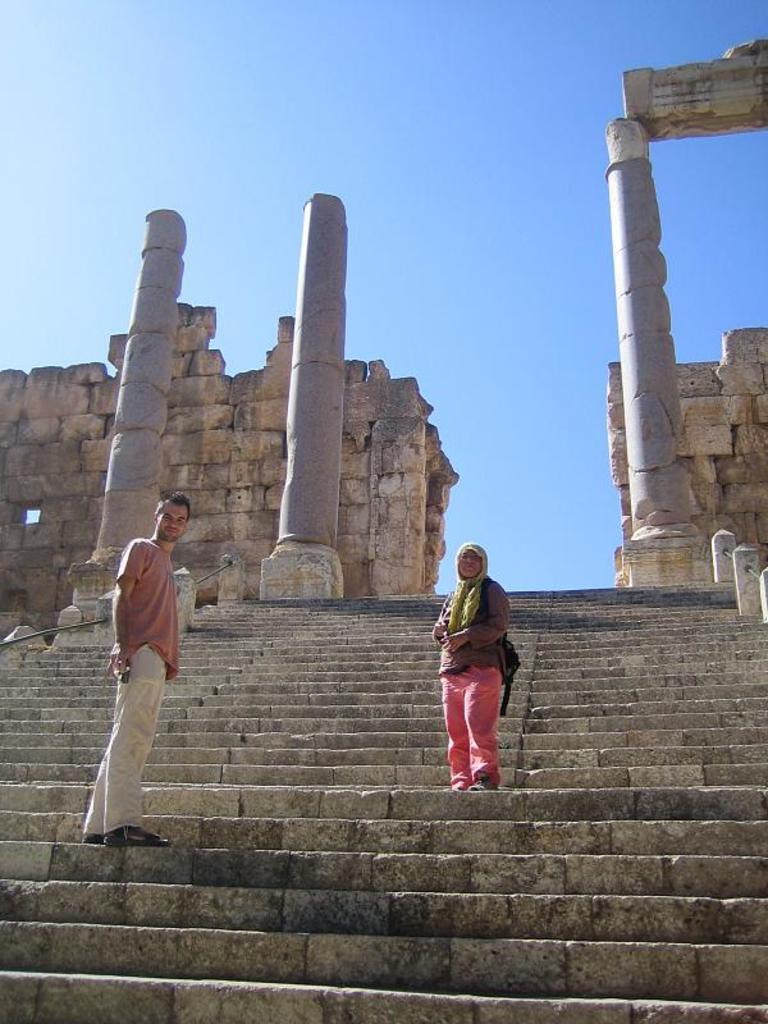Who are the people in the image? There is a man and a woman in the image. What are the man and woman doing in the image? The man and woman are standing on the steps. What can be seen in the background of the image? There are pillars and metal rods in the background of the image. What type of crime is being committed in the image? There is no crime being committed in the image; it simply shows a man and a woman standing on the steps. What is the connection between the man and woman and space in the image? There is no connection between the man, woman, and space in the image; it is an outdoor scene with no reference to space or space travel. 